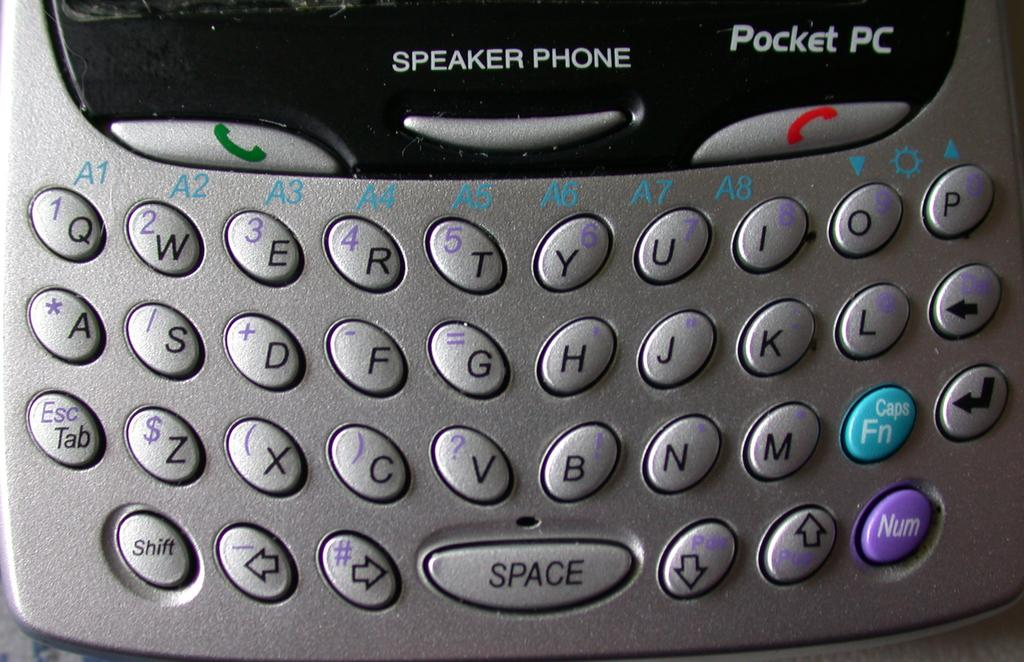Provide a one-sentence caption for the provided image. A pocket PC phone with a QWERTY keyboard. 